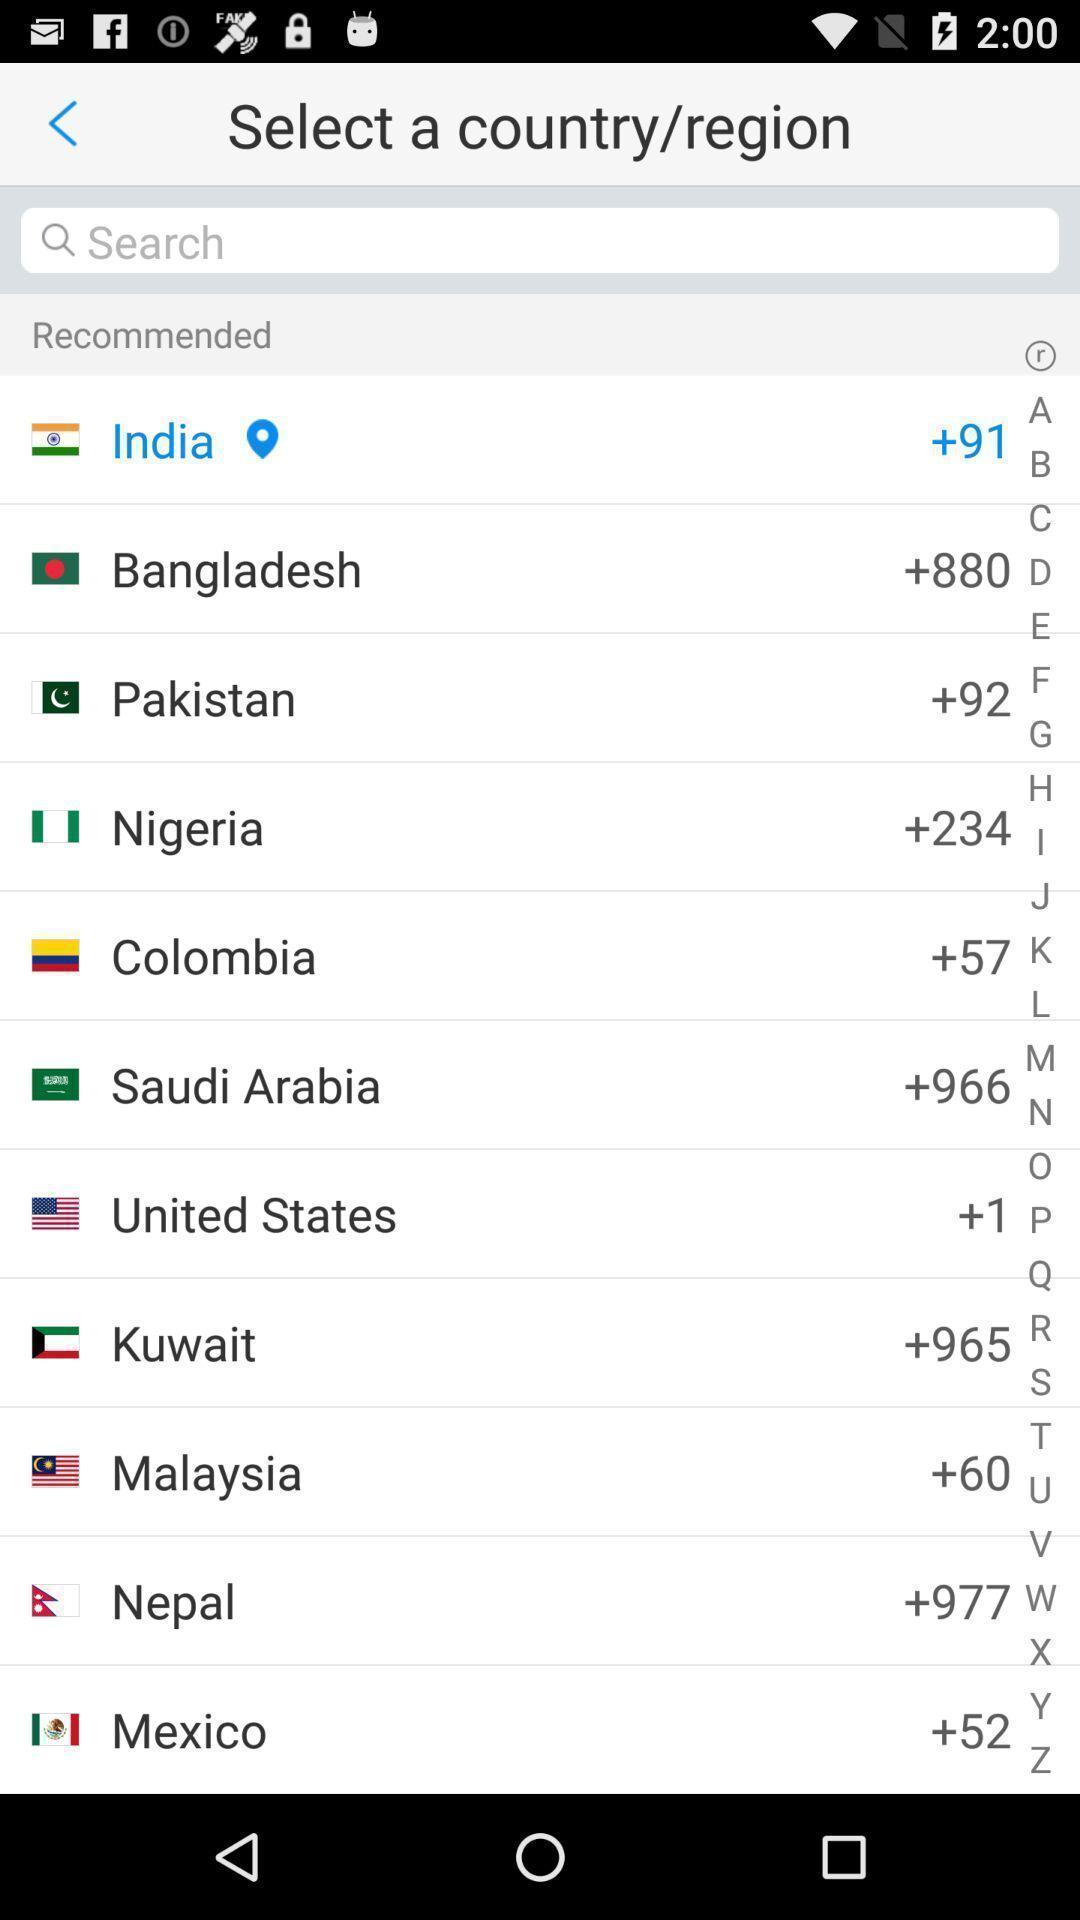Describe the visual elements of this screenshot. Page to select a country or region. 